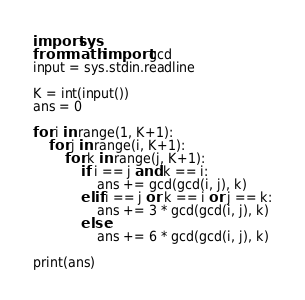<code> <loc_0><loc_0><loc_500><loc_500><_Python_>import sys
from math import gcd
input = sys.stdin.readline

K = int(input())
ans = 0

for i in range(1, K+1):
    for j in range(i, K+1):
        for k in range(j, K+1):
            if i == j and k == i:
                ans += gcd(gcd(i, j), k)
            elif i == j or k == i or j == k:
                ans += 3 * gcd(gcd(i, j), k)
            else:
                ans += 6 * gcd(gcd(i, j), k)

print(ans)
</code> 